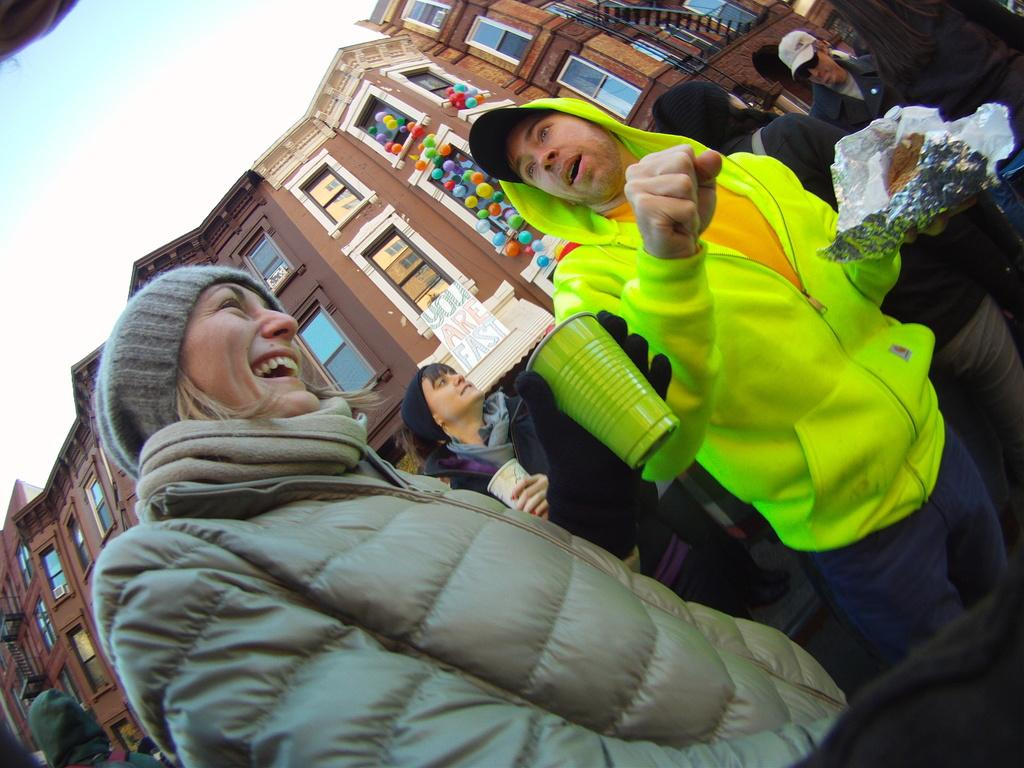What are the people in the image doing? The people in the image are standing and holding cups and papers. What objects are the people holding in the image? The people are holding cups and papers. What can be seen in the background of the image? There is a building and the sky visible in the background of the image. What type of string is being used to measure the wealth of the people in the image? There is no string or measurement of wealth present in the image. 